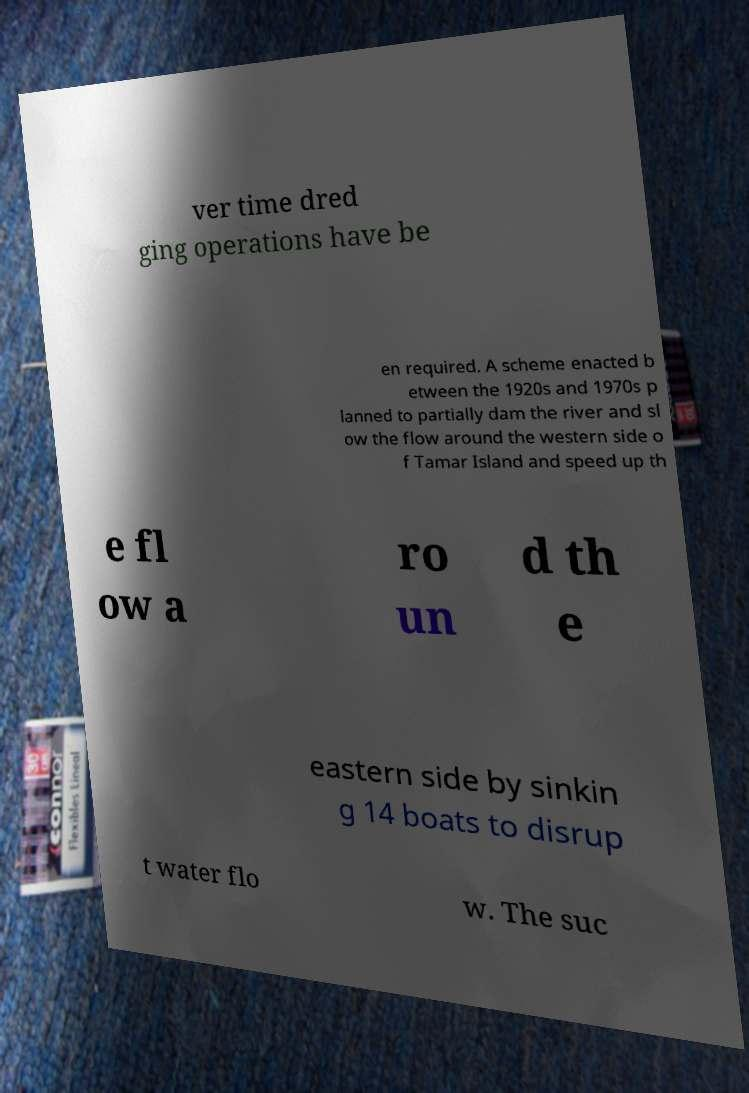Could you extract and type out the text from this image? ver time dred ging operations have be en required. A scheme enacted b etween the 1920s and 1970s p lanned to partially dam the river and sl ow the flow around the western side o f Tamar Island and speed up th e fl ow a ro un d th e eastern side by sinkin g 14 boats to disrup t water flo w. The suc 